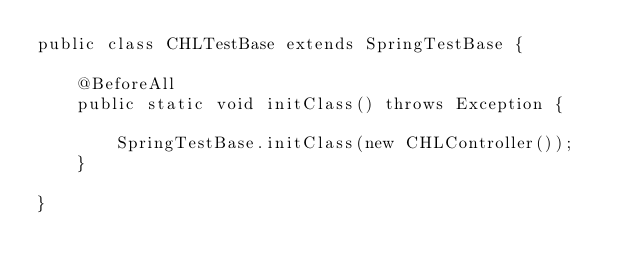Convert code to text. <code><loc_0><loc_0><loc_500><loc_500><_Java_>public class CHLTestBase extends SpringTestBase {

    @BeforeAll
    public static void initClass() throws Exception {

        SpringTestBase.initClass(new CHLController());
    }

}
</code> 